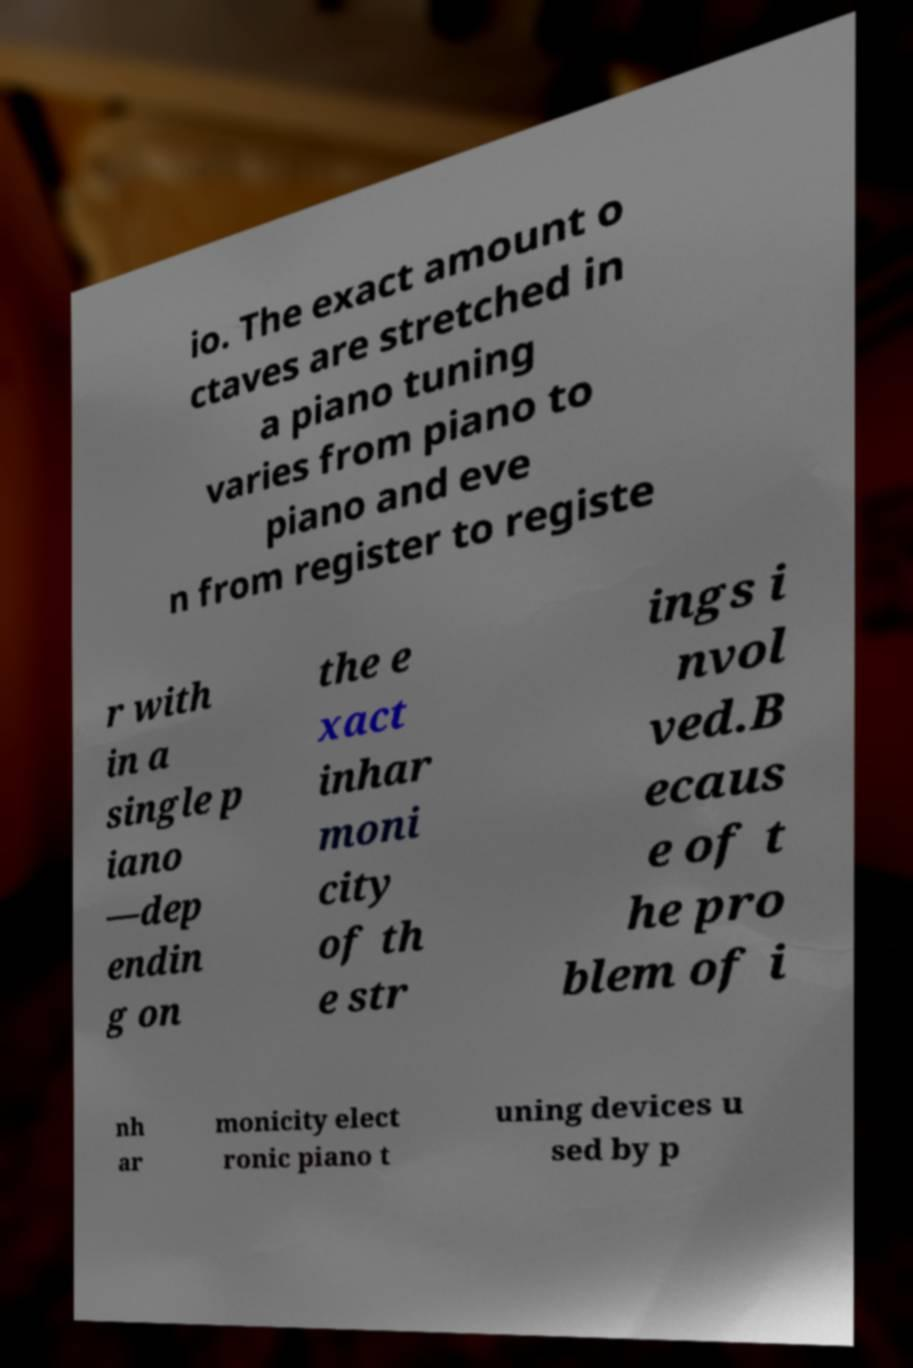Please identify and transcribe the text found in this image. io. The exact amount o ctaves are stretched in a piano tuning varies from piano to piano and eve n from register to registe r with in a single p iano —dep endin g on the e xact inhar moni city of th e str ings i nvol ved.B ecaus e of t he pro blem of i nh ar monicity elect ronic piano t uning devices u sed by p 